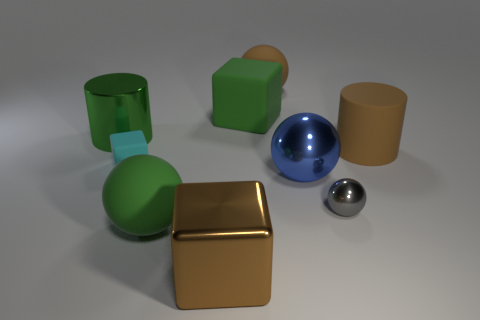Subtract all large metallic spheres. How many spheres are left? 3 Add 1 tiny metal balls. How many objects exist? 10 Subtract all brown cylinders. How many cylinders are left? 1 Subtract all cylinders. How many objects are left? 7 Subtract 2 blocks. How many blocks are left? 1 Subtract all blue matte cylinders. Subtract all balls. How many objects are left? 5 Add 8 green spheres. How many green spheres are left? 9 Add 4 green blocks. How many green blocks exist? 5 Subtract 0 blue blocks. How many objects are left? 9 Subtract all gray cylinders. Subtract all brown blocks. How many cylinders are left? 2 